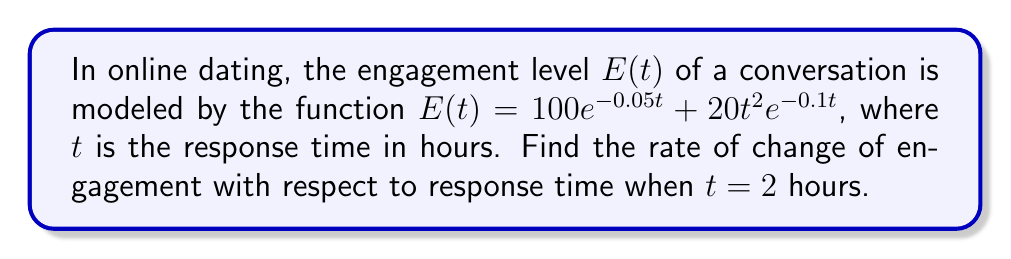Help me with this question. To find the rate of change of engagement with respect to response time, we need to differentiate $E(t)$ with respect to $t$ and then evaluate it at $t = 2$.

1) First, let's differentiate $E(t)$ using the product and chain rules:

   $$\frac{dE}{dt} = \frac{d}{dt}(100e^{-0.05t}) + \frac{d}{dt}(20t^2e^{-0.1t})$$

2) For the first term:
   $$\frac{d}{dt}(100e^{-0.05t}) = 100 \cdot (-0.05)e^{-0.05t} = -5e^{-0.05t}$$

3) For the second term, we use the product rule:
   $$\frac{d}{dt}(20t^2e^{-0.1t}) = 20 \cdot 2t \cdot e^{-0.1t} + 20t^2 \cdot (-0.1)e^{-0.1t}$$
   $$= 40te^{-0.1t} - 2t^2e^{-0.1t}$$

4) Combining the results:
   $$\frac{dE}{dt} = -5e^{-0.05t} + 40te^{-0.1t} - 2t^2e^{-0.1t}$$

5) Now, we evaluate this at $t = 2$:
   $$\frac{dE}{dt}\bigg|_{t=2} = -5e^{-0.1} + 80e^{-0.2} - 8e^{-0.2}$$

6) Simplifying:
   $$\frac{dE}{dt}\bigg|_{t=2} = -5e^{-0.1} + 72e^{-0.2}$$

This represents the instantaneous rate of change of engagement with respect to response time at 2 hours.
Answer: $-5e^{-0.1} + 72e^{-0.2}$ 